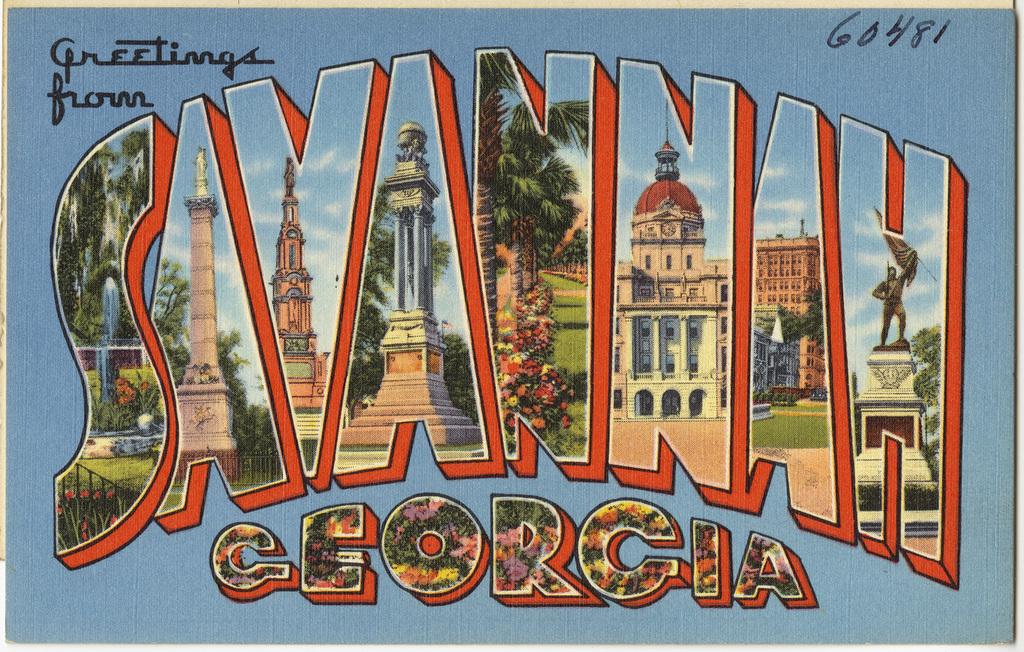Where is this ad promoting?
Provide a succinct answer. Savannah georgia. What us state is savannah in?
Provide a short and direct response. Georgia. 